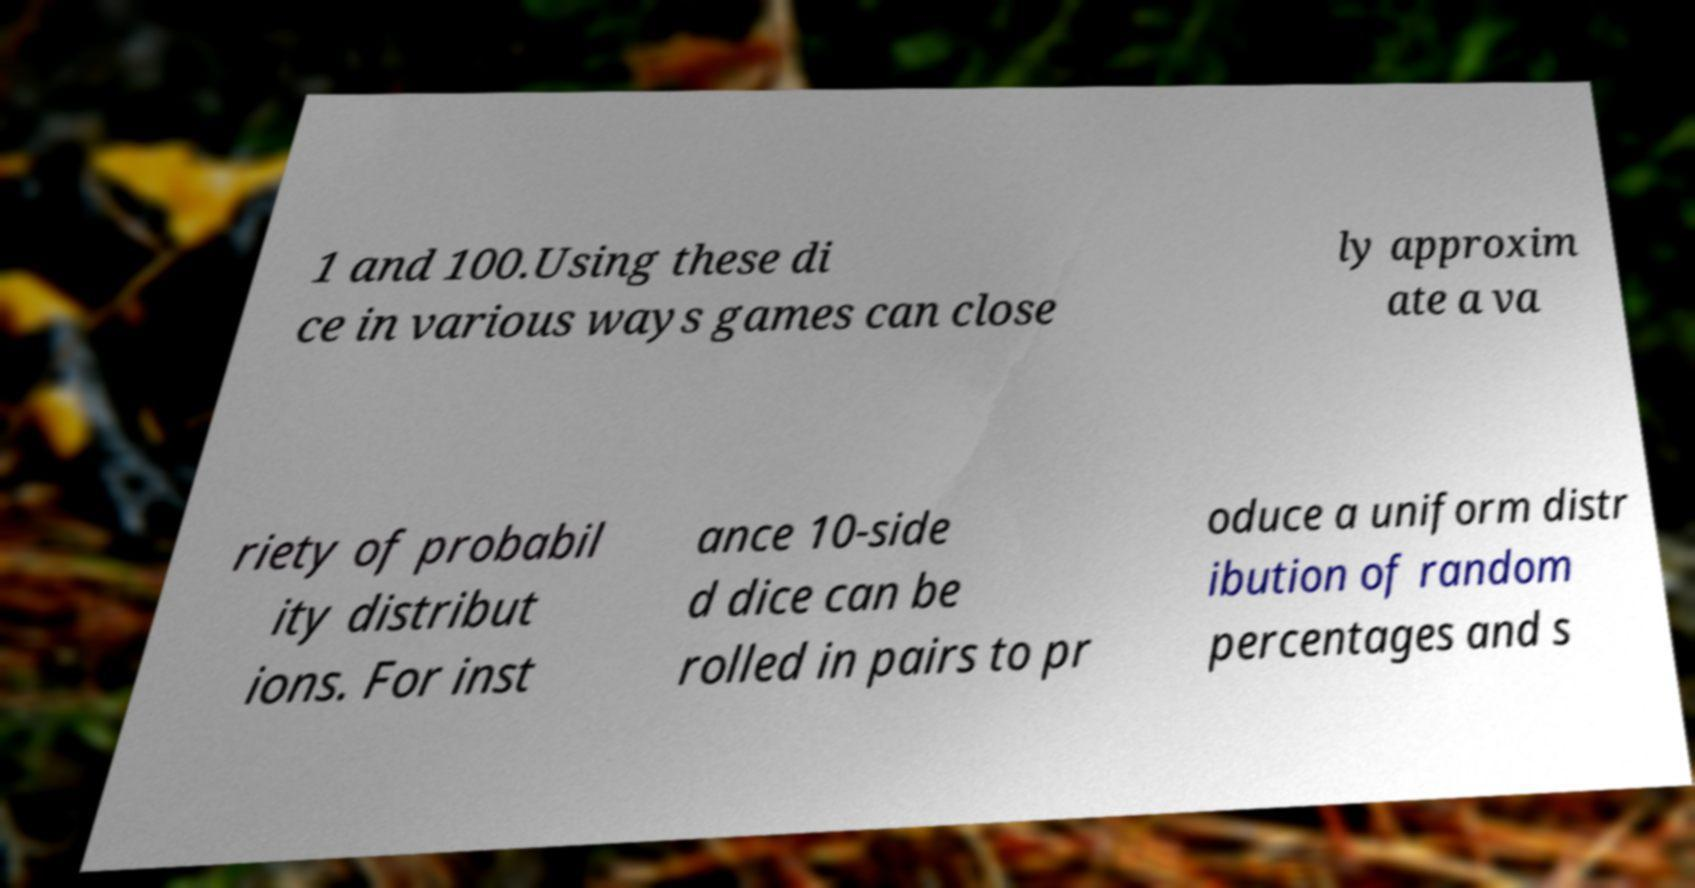Could you assist in decoding the text presented in this image and type it out clearly? 1 and 100.Using these di ce in various ways games can close ly approxim ate a va riety of probabil ity distribut ions. For inst ance 10-side d dice can be rolled in pairs to pr oduce a uniform distr ibution of random percentages and s 